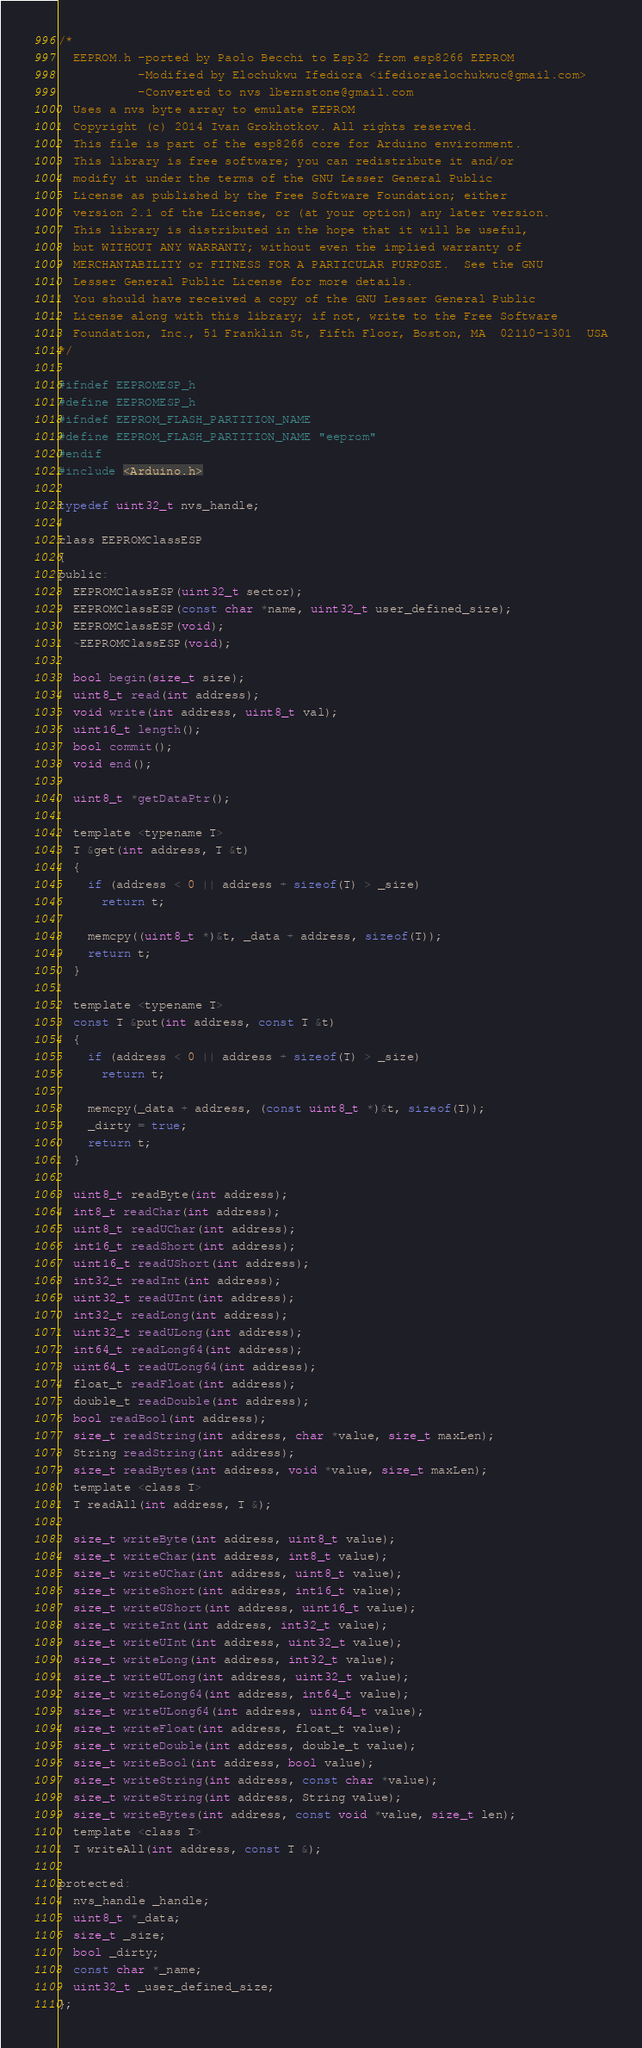Convert code to text. <code><loc_0><loc_0><loc_500><loc_500><_C_>/*
  EEPROM.h -ported by Paolo Becchi to Esp32 from esp8266 EEPROM
           -Modified by Elochukwu Ifediora <ifedioraelochukwuc@gmail.com>
           -Converted to nvs lbernstone@gmail.com
  Uses a nvs byte array to emulate EEPROM
  Copyright (c) 2014 Ivan Grokhotkov. All rights reserved.
  This file is part of the esp8266 core for Arduino environment.
  This library is free software; you can redistribute it and/or
  modify it under the terms of the GNU Lesser General Public
  License as published by the Free Software Foundation; either
  version 2.1 of the License, or (at your option) any later version.
  This library is distributed in the hope that it will be useful,
  but WITHOUT ANY WARRANTY; without even the implied warranty of
  MERCHANTABILITY or FITNESS FOR A PARTICULAR PURPOSE.  See the GNU
  Lesser General Public License for more details.
  You should have received a copy of the GNU Lesser General Public
  License along with this library; if not, write to the Free Software
  Foundation, Inc., 51 Franklin St, Fifth Floor, Boston, MA  02110-1301  USA
*/

#ifndef EEPROMESP_h
#define EEPROMESP_h
#ifndef EEPROM_FLASH_PARTITION_NAME
#define EEPROM_FLASH_PARTITION_NAME "eeprom"
#endif
#include <Arduino.h>

typedef uint32_t nvs_handle;

class EEPROMClassESP
{
public:
  EEPROMClassESP(uint32_t sector);
  EEPROMClassESP(const char *name, uint32_t user_defined_size);
  EEPROMClassESP(void);
  ~EEPROMClassESP(void);

  bool begin(size_t size);
  uint8_t read(int address);
  void write(int address, uint8_t val);
  uint16_t length();
  bool commit();
  void end();

  uint8_t *getDataPtr();

  template <typename T>
  T &get(int address, T &t)
  {
    if (address < 0 || address + sizeof(T) > _size)
      return t;

    memcpy((uint8_t *)&t, _data + address, sizeof(T));
    return t;
  }

  template <typename T>
  const T &put(int address, const T &t)
  {
    if (address < 0 || address + sizeof(T) > _size)
      return t;

    memcpy(_data + address, (const uint8_t *)&t, sizeof(T));
    _dirty = true;
    return t;
  }

  uint8_t readByte(int address);
  int8_t readChar(int address);
  uint8_t readUChar(int address);
  int16_t readShort(int address);
  uint16_t readUShort(int address);
  int32_t readInt(int address);
  uint32_t readUInt(int address);
  int32_t readLong(int address);
  uint32_t readULong(int address);
  int64_t readLong64(int address);
  uint64_t readULong64(int address);
  float_t readFloat(int address);
  double_t readDouble(int address);
  bool readBool(int address);
  size_t readString(int address, char *value, size_t maxLen);
  String readString(int address);
  size_t readBytes(int address, void *value, size_t maxLen);
  template <class T>
  T readAll(int address, T &);

  size_t writeByte(int address, uint8_t value);
  size_t writeChar(int address, int8_t value);
  size_t writeUChar(int address, uint8_t value);
  size_t writeShort(int address, int16_t value);
  size_t writeUShort(int address, uint16_t value);
  size_t writeInt(int address, int32_t value);
  size_t writeUInt(int address, uint32_t value);
  size_t writeLong(int address, int32_t value);
  size_t writeULong(int address, uint32_t value);
  size_t writeLong64(int address, int64_t value);
  size_t writeULong64(int address, uint64_t value);
  size_t writeFloat(int address, float_t value);
  size_t writeDouble(int address, double_t value);
  size_t writeBool(int address, bool value);
  size_t writeString(int address, const char *value);
  size_t writeString(int address, String value);
  size_t writeBytes(int address, const void *value, size_t len);
  template <class T>
  T writeAll(int address, const T &);

protected:
  nvs_handle _handle;
  uint8_t *_data;
  size_t _size;
  bool _dirty;
  const char *_name;
  uint32_t _user_defined_size;
};
</code> 